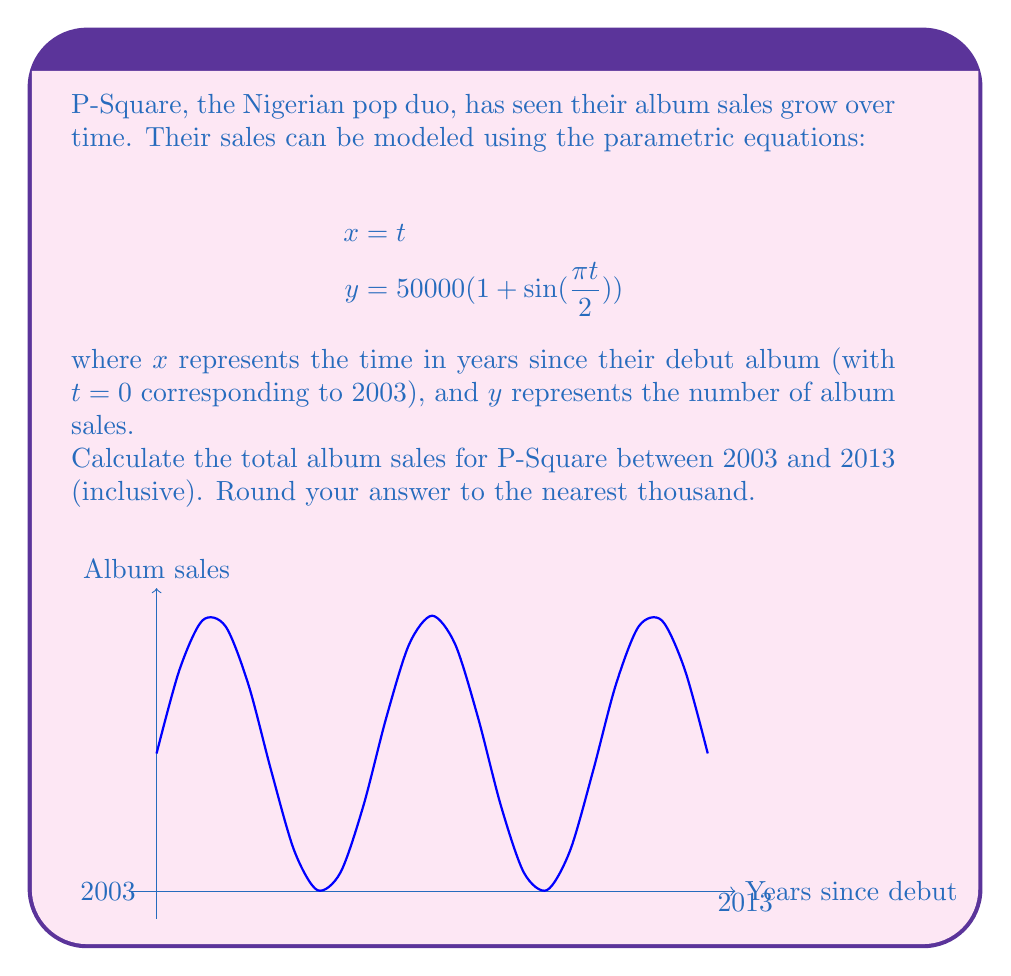Show me your answer to this math problem. To solve this problem, we need to follow these steps:

1) The given time period is from 2003 to 2013, which corresponds to $t=0$ to $t=10$ in our parametric equations.

2) To find the total sales, we need to integrate the $y$ equation with respect to $t$ from 0 to 10:

   $$\int_0^{10} 50000(1 + \sin(\frac{\pi t}{2})) dt$$

3) Let's break this into two parts:
   
   $$50000 \int_0^{10} dt + 50000 \int_0^{10} \sin(\frac{\pi t}{2}) dt$$

4) The first part is straightforward:
   
   $$50000 \cdot 10 = 500000$$

5) For the second part, we use the substitution $u = \frac{\pi t}{2}$, $du = \frac{\pi}{2} dt$:

   $$50000 \cdot \frac{2}{\pi} \int_0^{5\pi} \sin(u) du$$

6) Evaluating this:

   $$50000 \cdot \frac{2}{\pi} [-\cos(u)]_0^{5\pi} = 50000 \cdot \frac{2}{\pi} [(-\cos(5\pi)) - (-\cos(0))]$$
   $$= 50000 \cdot \frac{2}{\pi} [1 - 1] = 0$$

7) Adding the results from steps 4 and 6:

   $$500000 + 0 = 500000$$

8) Rounding to the nearest thousand:

   $$500000$$
Answer: 500,000 album sales 